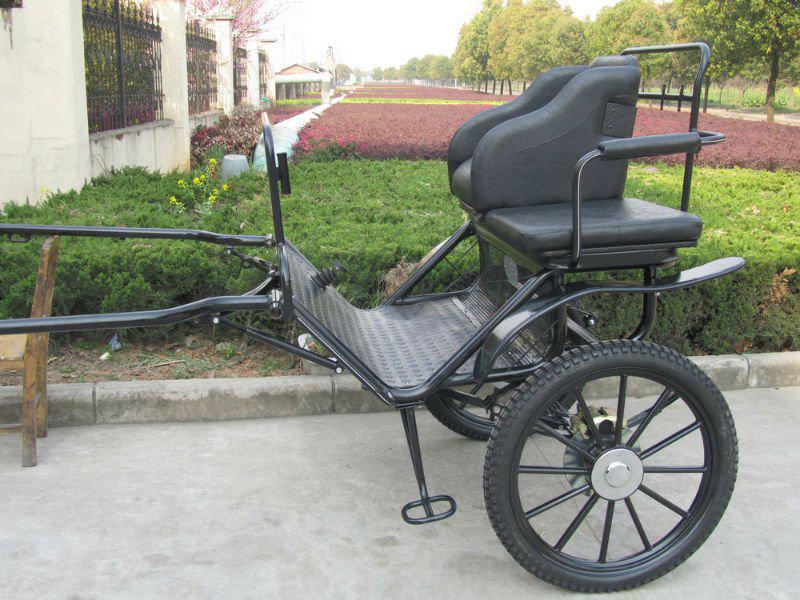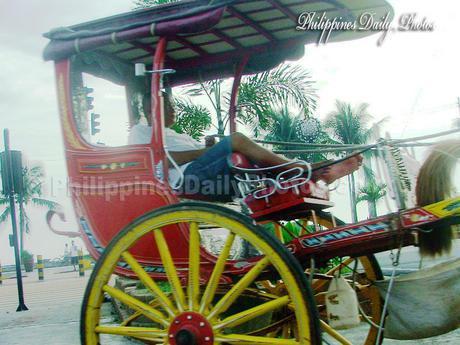The first image is the image on the left, the second image is the image on the right. Analyze the images presented: Is the assertion "One of the images has someone riding a horse carriage." valid? Answer yes or no. Yes. The first image is the image on the left, the second image is the image on the right. Assess this claim about the two images: "There at least one person shown in one or both of the images.". Correct or not? Answer yes or no. Yes. 